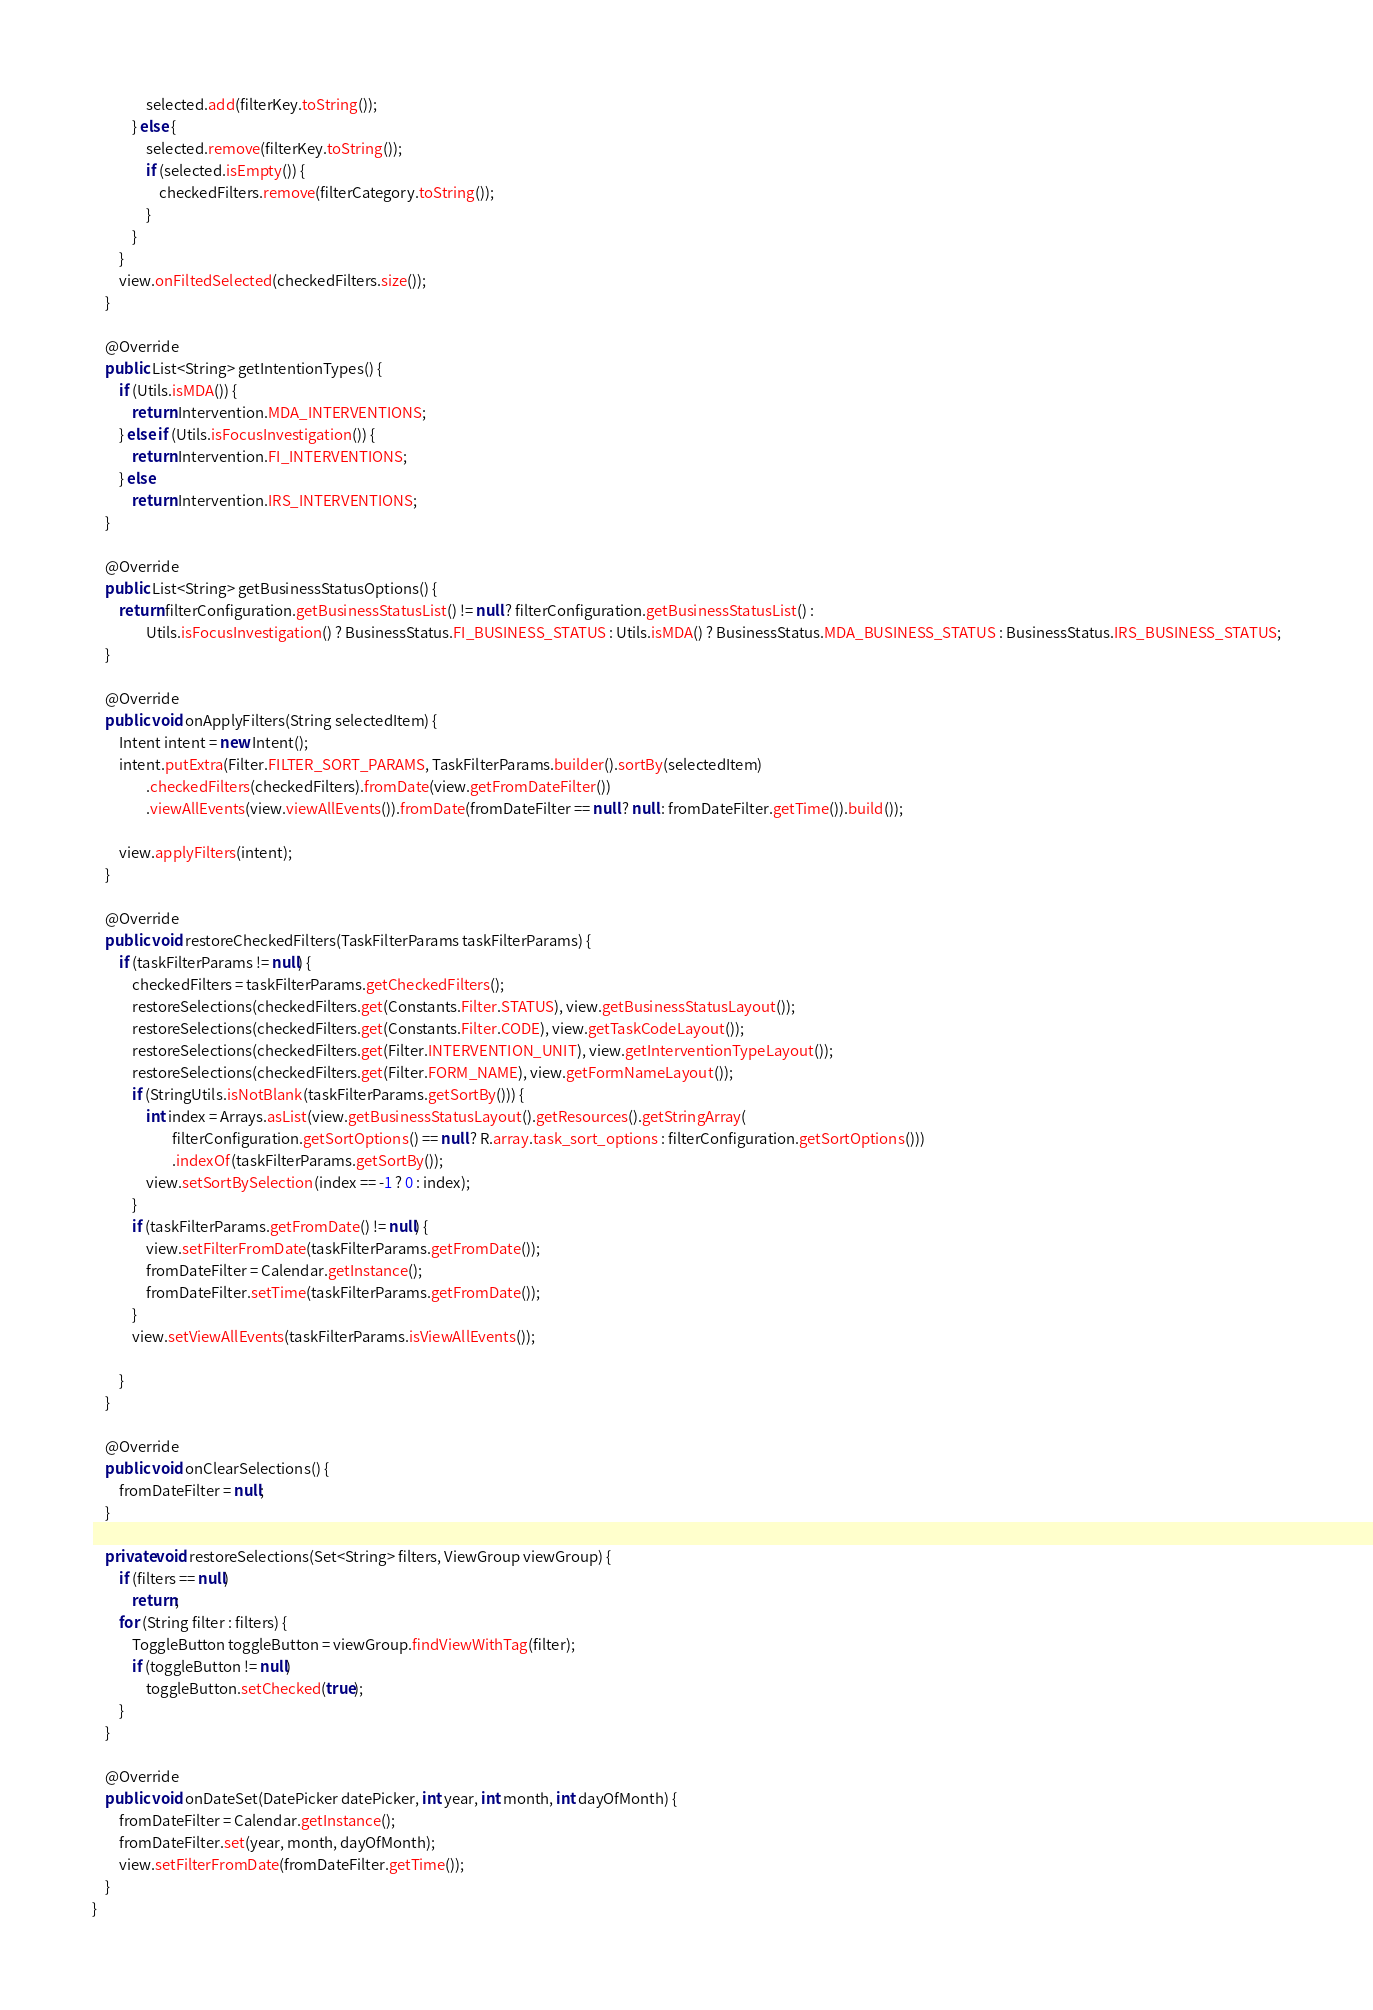<code> <loc_0><loc_0><loc_500><loc_500><_Java_>                selected.add(filterKey.toString());
            } else {
                selected.remove(filterKey.toString());
                if (selected.isEmpty()) {
                    checkedFilters.remove(filterCategory.toString());
                }
            }
        }
        view.onFiltedSelected(checkedFilters.size());
    }

    @Override
    public List<String> getIntentionTypes() {
        if (Utils.isMDA()) {
            return Intervention.MDA_INTERVENTIONS;
        } else if (Utils.isFocusInvestigation()) {
            return Intervention.FI_INTERVENTIONS;
        } else
            return Intervention.IRS_INTERVENTIONS;
    }

    @Override
    public List<String> getBusinessStatusOptions() {
        return filterConfiguration.getBusinessStatusList() != null ? filterConfiguration.getBusinessStatusList() :
                Utils.isFocusInvestigation() ? BusinessStatus.FI_BUSINESS_STATUS : Utils.isMDA() ? BusinessStatus.MDA_BUSINESS_STATUS : BusinessStatus.IRS_BUSINESS_STATUS;
    }

    @Override
    public void onApplyFilters(String selectedItem) {
        Intent intent = new Intent();
        intent.putExtra(Filter.FILTER_SORT_PARAMS, TaskFilterParams.builder().sortBy(selectedItem)
                .checkedFilters(checkedFilters).fromDate(view.getFromDateFilter())
                .viewAllEvents(view.viewAllEvents()).fromDate(fromDateFilter == null ? null : fromDateFilter.getTime()).build());

        view.applyFilters(intent);
    }

    @Override
    public void restoreCheckedFilters(TaskFilterParams taskFilterParams) {
        if (taskFilterParams != null) {
            checkedFilters = taskFilterParams.getCheckedFilters();
            restoreSelections(checkedFilters.get(Constants.Filter.STATUS), view.getBusinessStatusLayout());
            restoreSelections(checkedFilters.get(Constants.Filter.CODE), view.getTaskCodeLayout());
            restoreSelections(checkedFilters.get(Filter.INTERVENTION_UNIT), view.getInterventionTypeLayout());
            restoreSelections(checkedFilters.get(Filter.FORM_NAME), view.getFormNameLayout());
            if (StringUtils.isNotBlank(taskFilterParams.getSortBy())) {
                int index = Arrays.asList(view.getBusinessStatusLayout().getResources().getStringArray(
                        filterConfiguration.getSortOptions() == null ? R.array.task_sort_options : filterConfiguration.getSortOptions()))
                        .indexOf(taskFilterParams.getSortBy());
                view.setSortBySelection(index == -1 ? 0 : index);
            }
            if (taskFilterParams.getFromDate() != null) {
                view.setFilterFromDate(taskFilterParams.getFromDate());
                fromDateFilter = Calendar.getInstance();
                fromDateFilter.setTime(taskFilterParams.getFromDate());
            }
            view.setViewAllEvents(taskFilterParams.isViewAllEvents());

        }
    }

    @Override
    public void onClearSelections() {
        fromDateFilter = null;
    }

    private void restoreSelections(Set<String> filters, ViewGroup viewGroup) {
        if (filters == null)
            return;
        for (String filter : filters) {
            ToggleButton toggleButton = viewGroup.findViewWithTag(filter);
            if (toggleButton != null)
                toggleButton.setChecked(true);
        }
    }

    @Override
    public void onDateSet(DatePicker datePicker, int year, int month, int dayOfMonth) {
        fromDateFilter = Calendar.getInstance();
        fromDateFilter.set(year, month, dayOfMonth);
        view.setFilterFromDate(fromDateFilter.getTime());
    }
}
</code> 